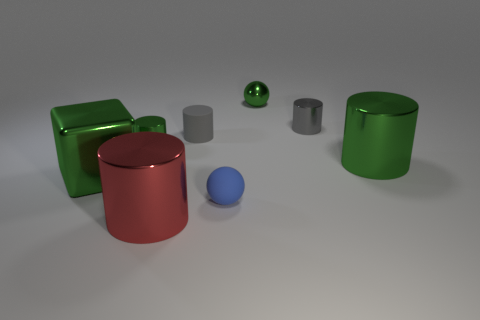Subtract 1 spheres. How many spheres are left? 1 Add 2 big cylinders. How many objects exist? 10 Subtract 1 green spheres. How many objects are left? 7 Subtract all cylinders. How many objects are left? 3 Subtract all green spheres. Subtract all green cubes. How many spheres are left? 1 Subtract all cyan cylinders. How many green balls are left? 1 Subtract all small green metallic cylinders. Subtract all small gray cylinders. How many objects are left? 5 Add 1 tiny shiny cylinders. How many tiny shiny cylinders are left? 3 Add 7 green cylinders. How many green cylinders exist? 9 Subtract all red cylinders. How many cylinders are left? 4 